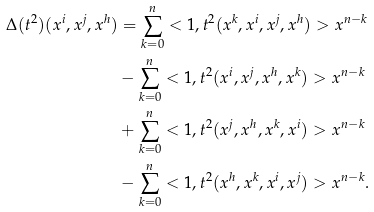Convert formula to latex. <formula><loc_0><loc_0><loc_500><loc_500>\Delta ( t ^ { 2 } ) ( x ^ { i } , x ^ { j } , x ^ { h } ) & = \sum _ { k = 0 } ^ { n } < 1 , t ^ { 2 } ( x ^ { k } , x ^ { i } , x ^ { j } , x ^ { h } ) > x ^ { n - k } \\ & - \sum _ { k = 0 } ^ { n } < 1 , t ^ { 2 } ( x ^ { i } , x ^ { j } , x ^ { h } , x ^ { k } ) > x ^ { n - k } \\ & + \sum _ { k = 0 } ^ { n } < 1 , t ^ { 2 } ( x ^ { j } , x ^ { h } , x ^ { k } , x ^ { i } ) > x ^ { n - k } \\ & - \sum _ { k = 0 } ^ { n } < 1 , t ^ { 2 } ( x ^ { h } , x ^ { k } , x ^ { i } , x ^ { j } ) > x ^ { n - k } . \\</formula> 